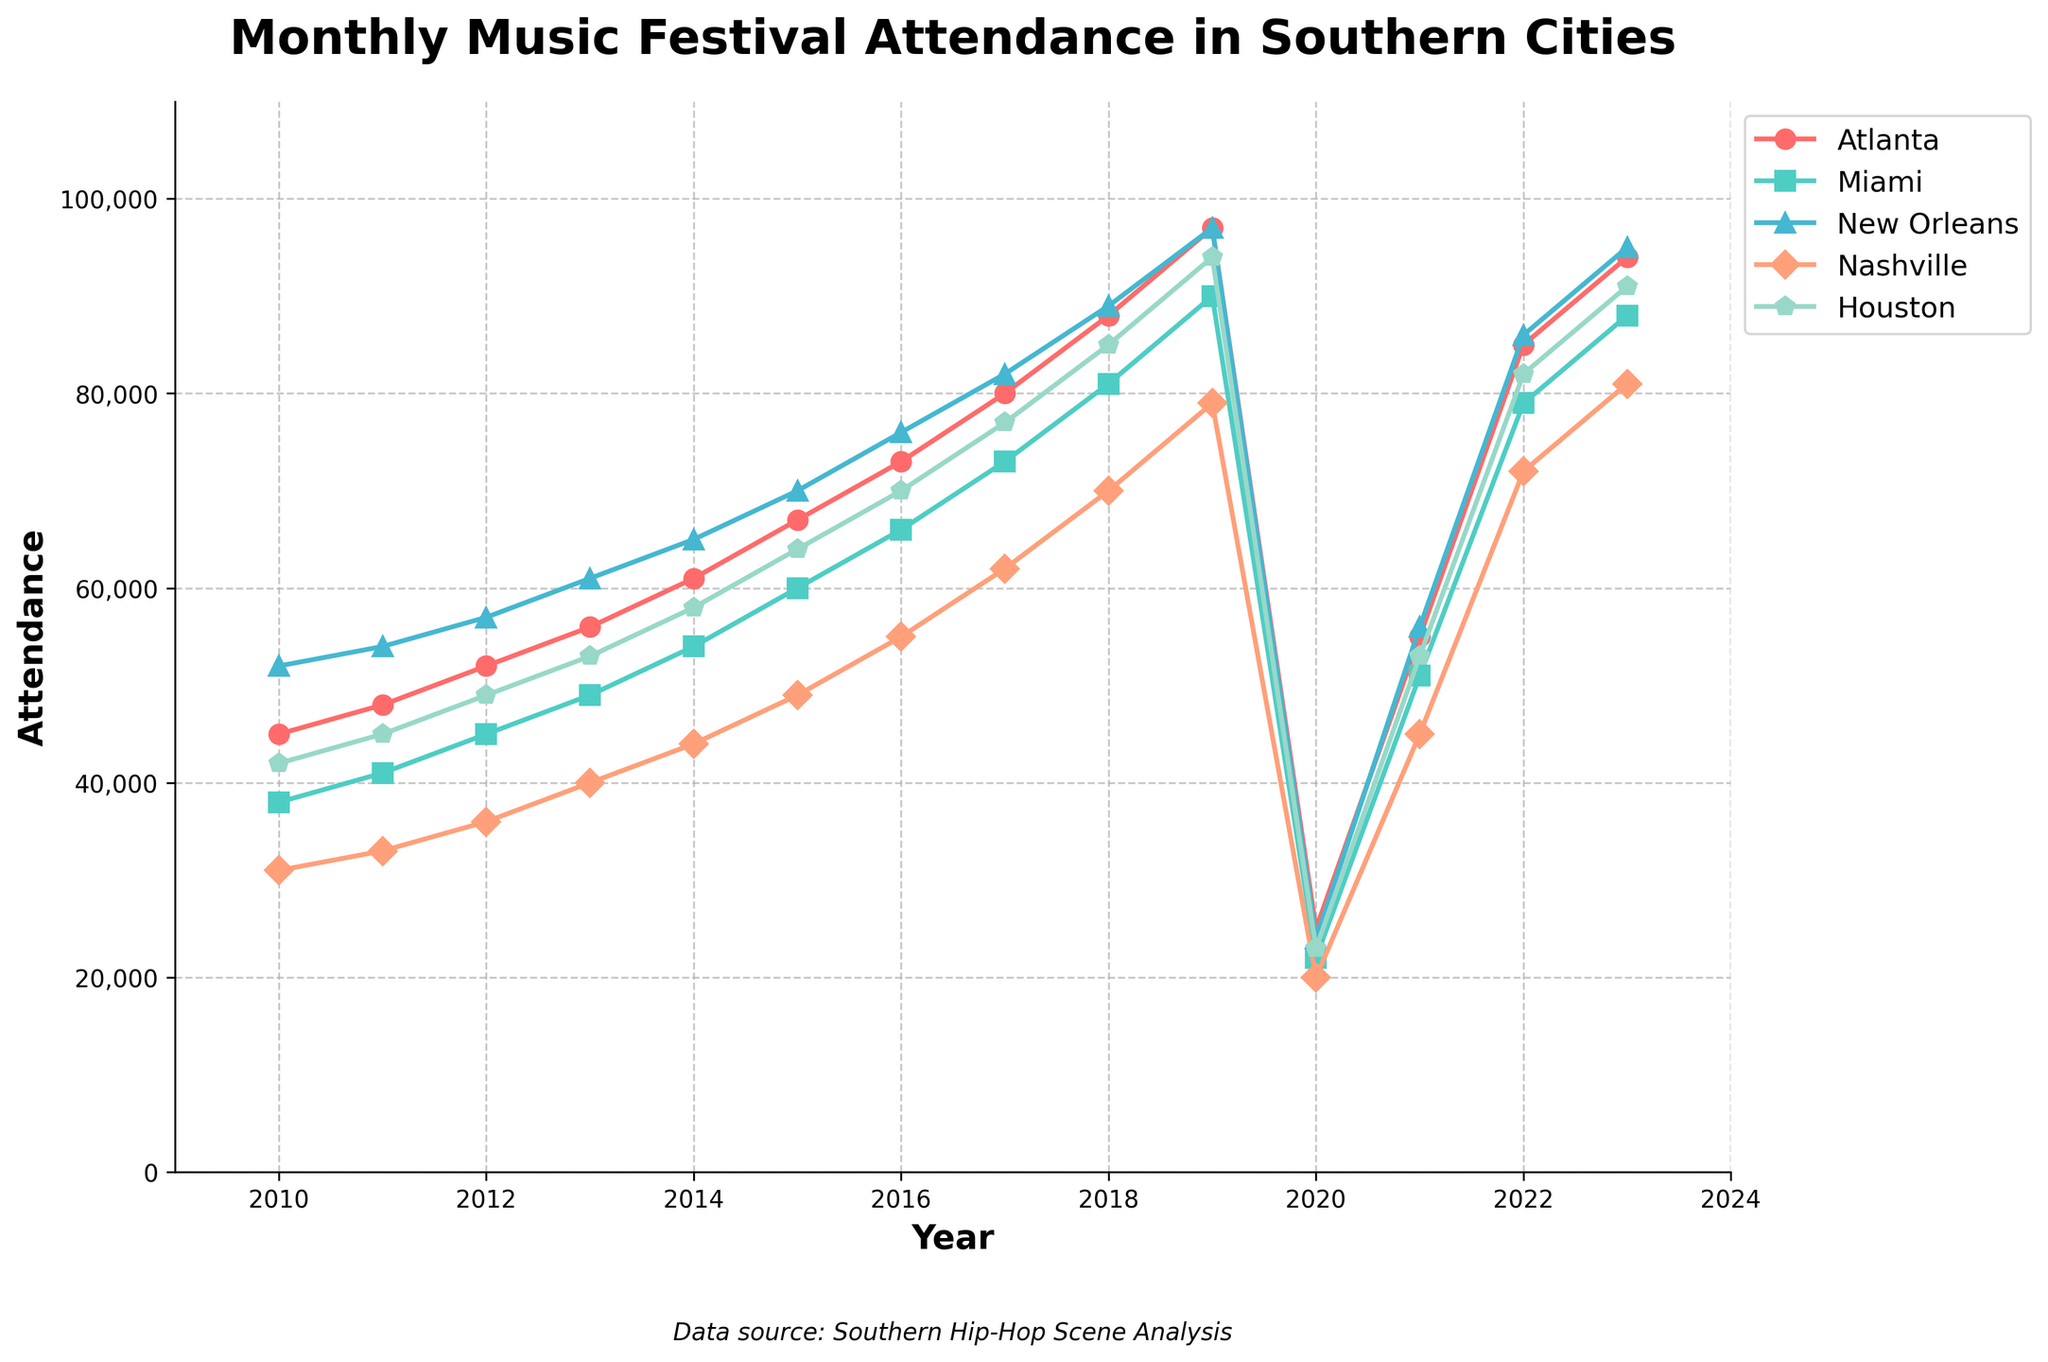What's the average attendance in Miami over the years 2010 to 2023? To find the average attendance in Miami, sum the attendance values for each year from 2010 to 2023 and divide by the number of years (14). The sum is 38000 + 41000 + 45000 + 49000 + 54000 + 60000 + 66000 + 73000 + 81000 + 90000 + 22000 + 51000 + 79000 + 88000 = 937000. Dividing by 14 gives an average attendance of 66929.
Answer: 66929 Which city had the highest attendance in 2023? To determine the city with the highest attendance in 2023, compare the attendance values for each city. In 2023, Atlanta had 94000, Miami had 88000, New Orleans had 95000, Nashville had 81000, and Houston had 91000. New Orleans had the highest attendance with 95000.
Answer: New Orleans What was the total attendance for all cities combined in 2020? Sum the attendance values for all cities in 2020. Atlanta had 25000, Miami had 22000, New Orleans had 24000, Nashville had 20000, and Houston had 23000. The total attendance is 25000 + 22000 + 24000 + 20000 + 23000 = 114000.
Answer: 114000 How did the attendance in Nashville change from 2010 to 2019? Calculate the difference between Nashville's attendance in 2019 and 2010. The attendance in 2010 was 31000, and in 2019, it was 79000. The change is 79000 - 31000 = 48000. Nashville's attendance increased by 48000.
Answer: increased by 48000 Which city experienced the largest drop in attendance from 2019 to 2020? To find the largest drop, calculate the difference in attendance for each city from 2019 to 2020. Atlanta dropped by 97000 - 25000 = 72000, Miami by 90000 - 22000 = 68000, New Orleans by 97000 - 24000 = 73000, Nashville by 79000 - 20000 = 59000, and Houston by 94000 - 23000 = 71000. New Orleans experienced the largest drop of 73000.
Answer: New Orleans What is the overall trend in attendance for Houston from 2010 to 2023? Observe the general pattern of attendance values for Houston from 2010 to 2023. The values are 42000, 45000, 49000, 53000, 58000, 64000, 70000, 77000, 85000, 94000, 23000, 53000, 82000, and 91000. The overall trend shows a rise each year with a sharp decline in 2020, but a recovery in subsequent years. The overall trend is increasing.
Answer: Increasing By what percentage did Atlanta's attendance increase from 2012 to 2013? Calculate the percentage increase using the formula ((new value - old value) / old value) * 100. In 2012, Atlanta's attendance was 52000, and in 2013 it was 56000. The increase is (56000 - 52000) / 52000 * 100 = 7.69%.
Answer: 7.69% Which year saw the lowest attendance across all cities combined? Sum the attendance for each year and identify the year with the lowest total. 2020 had the combined attendance of 114000, which is the lowest.
Answer: 2020 In which year did New Orleans see its highest attendance? Compare the attendance values for New Orleans across all years. The highest value is 97,000, which occurred in 2019.
Answer: 2019 